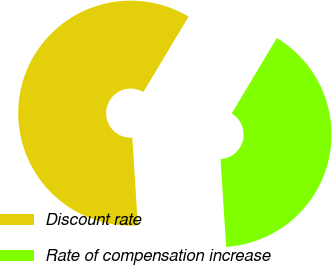<chart> <loc_0><loc_0><loc_500><loc_500><pie_chart><fcel>Discount rate<fcel>Rate of compensation increase<nl><fcel>59.6%<fcel>40.4%<nl></chart> 